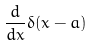<formula> <loc_0><loc_0><loc_500><loc_500>\frac { d } { d x } \delta ( x - a )</formula> 